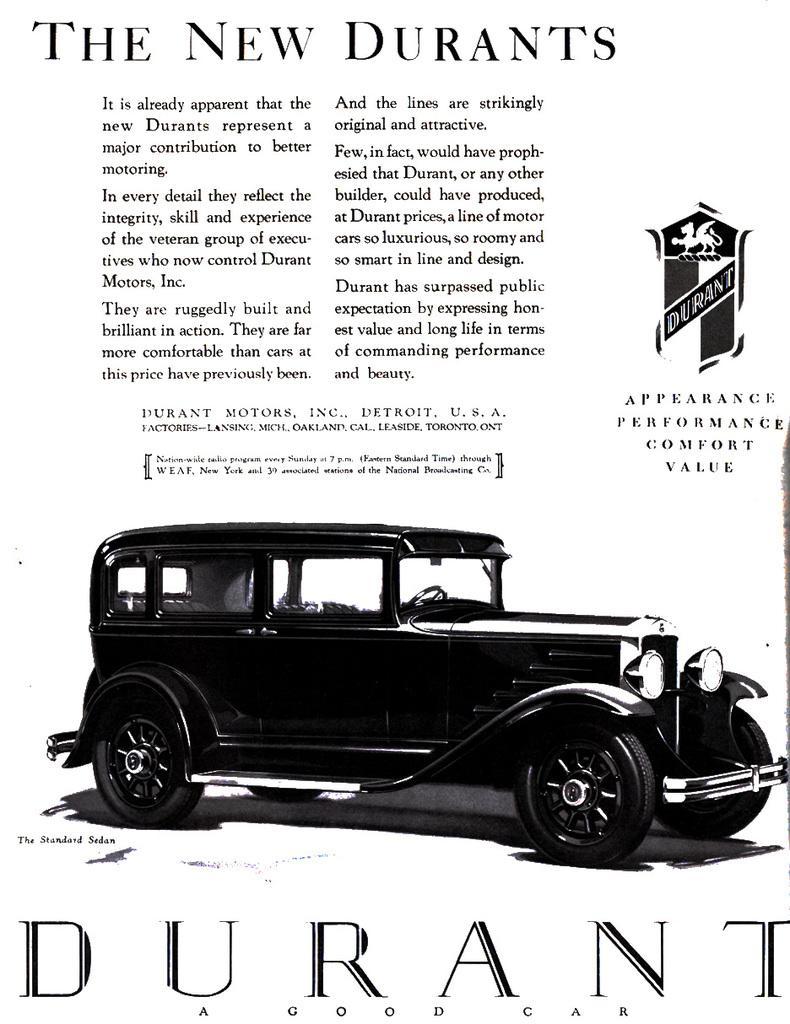Describe this image in one or two sentences. In this image there is a black and white poster, in that poster there is a car and some text is written on that poster. 